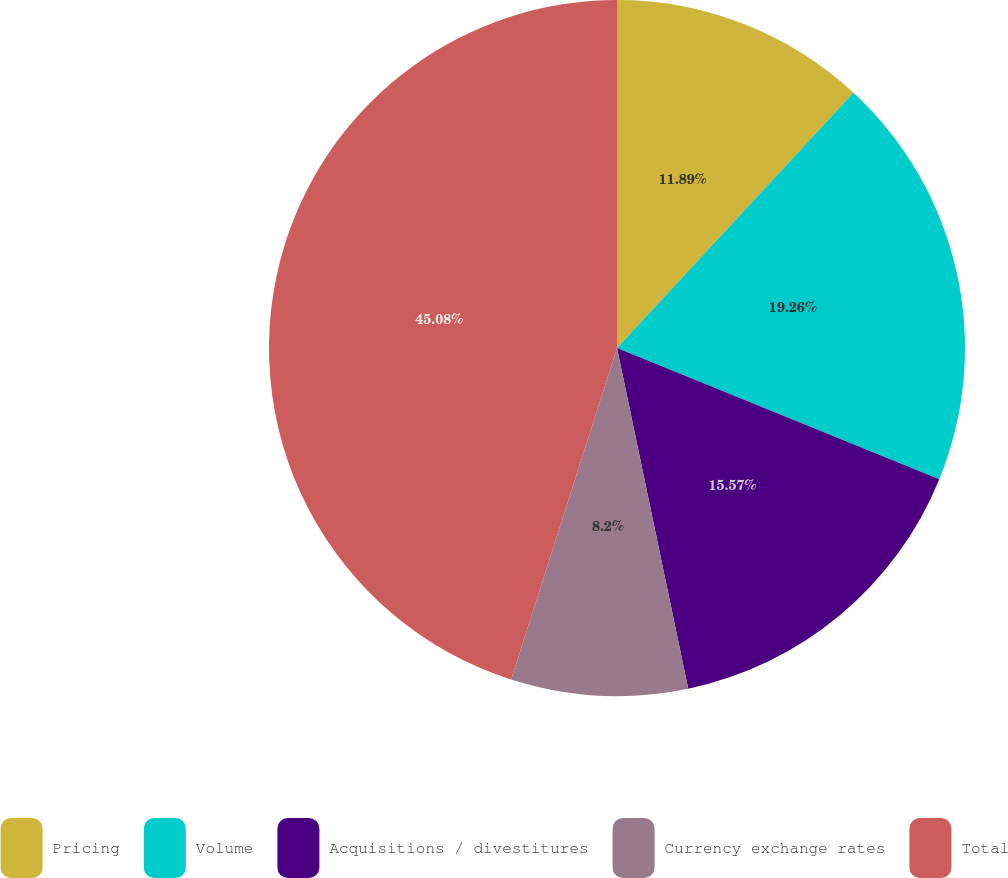Convert chart to OTSL. <chart><loc_0><loc_0><loc_500><loc_500><pie_chart><fcel>Pricing<fcel>Volume<fcel>Acquisitions / divestitures<fcel>Currency exchange rates<fcel>Total<nl><fcel>11.89%<fcel>19.26%<fcel>15.57%<fcel>8.2%<fcel>45.08%<nl></chart> 